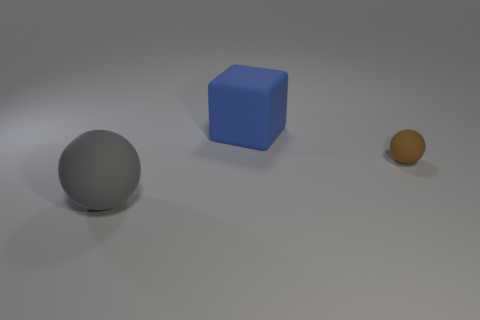Add 3 blue matte objects. How many objects exist? 6 Subtract all spheres. How many objects are left? 1 Subtract all big blue objects. Subtract all small brown balls. How many objects are left? 1 Add 1 brown objects. How many brown objects are left? 2 Add 3 small spheres. How many small spheres exist? 4 Subtract 0 yellow spheres. How many objects are left? 3 Subtract all purple blocks. Subtract all brown spheres. How many blocks are left? 1 